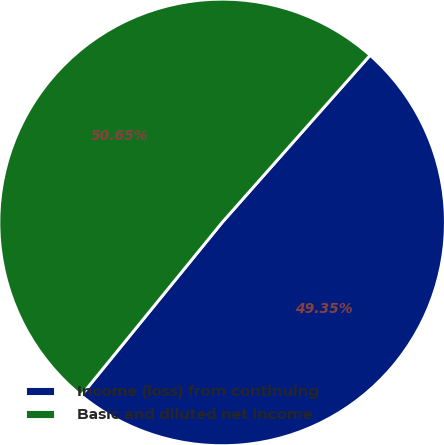<chart> <loc_0><loc_0><loc_500><loc_500><pie_chart><fcel>Income (loss) from continuing<fcel>Basic and diluted net income<nl><fcel>49.35%<fcel>50.65%<nl></chart> 